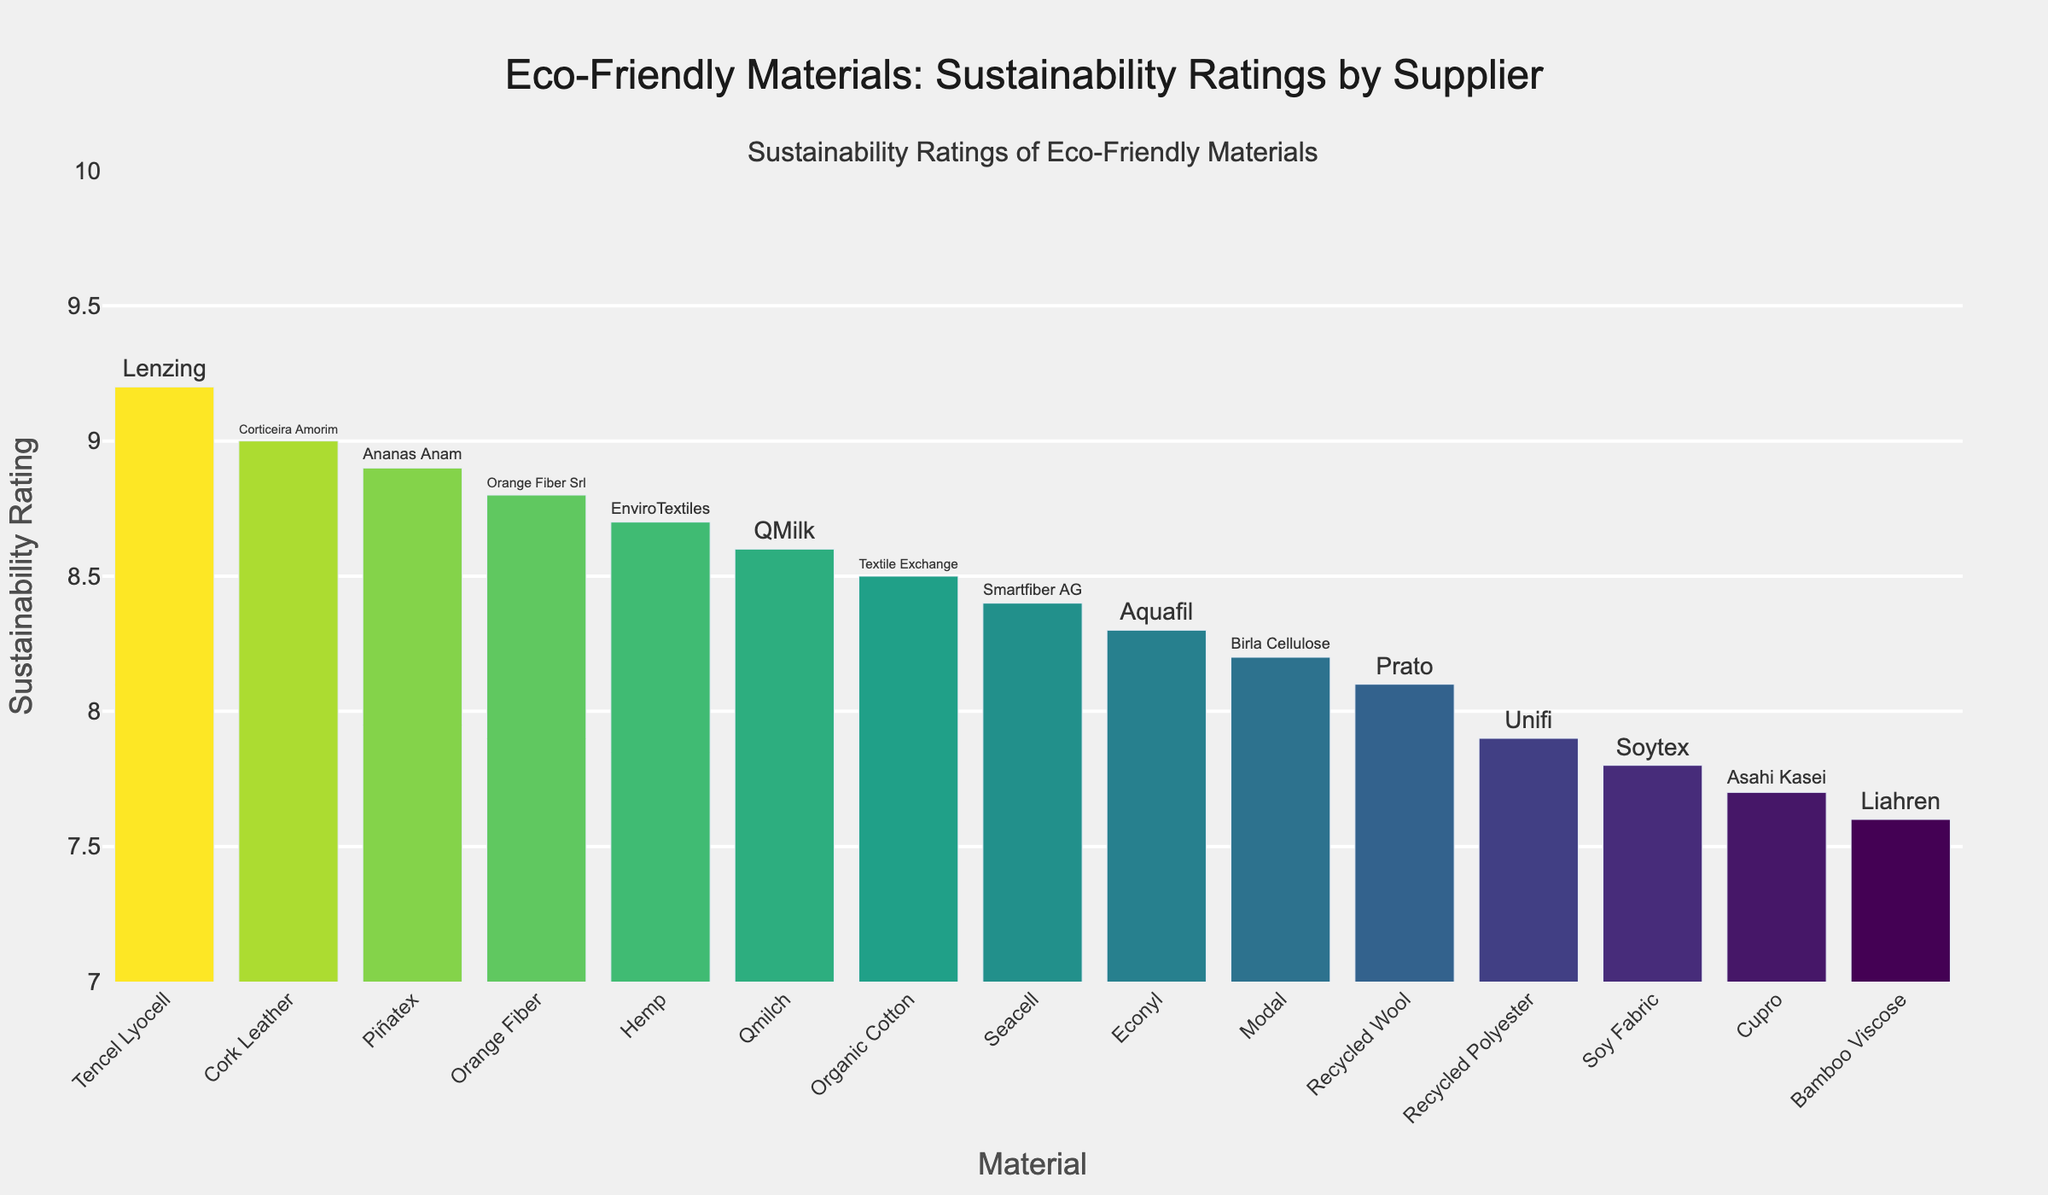What's the material with the highest sustainability rating? The material with the highest bar on the chart is Tencel Lyocell with a rating of 9.2, as indicated at the top of its bar.
Answer: Tencel Lyocell Which material has a higher sustainability rating, Hemp or Bamboo Viscose? By comparing the heights of the two bars, Hemp has a rating of 8.7 while Bamboo Viscose has a rating of 7.6, making Hemp the higher rated material.
Answer: Hemp What is the average sustainability rating of the materials supplied by Textile Exchange and Aquafil? Textile Exchange provides Organic Cotton with a rating of 8.5, and Aquafil supplies Econyl rated at 8.3. Average = (8.5 + 8.3) / 2 = 8.4.
Answer: 8.4 How many materials have a sustainability rating greater than 8.5? Counting the bars higher than 8.5: Tencel Lyocell, Piñatex, Cork Leather, Orange Fiber, Qmilch, and Hemp. This makes a total of 6 materials.
Answer: 6 Which suppliers provide materials with sustainability ratings of exactly 8.9? The bar labeled 8.9 corresponds to Piñatex, which is provided by Ananas Anam.
Answer: Ananas Anam Which material provided by Birla Cellulose, and what is its sustainability rating? By checking the bar labeled with the supplier Birla Cellulose, it corresponds to Modal with a rating of 8.2.
Answer: Modal, 8.2 What is the difference in sustainability ratings between Cupro and Seacell? Cupro has a rating of 7.7, while Seacell is rated at 8.4. Difference = 8.4 - 7.7 = 0.7.
Answer: 0.7 Out of the materials with ratings between 8.0 and 8.5, which is the least sustainable? Materials with ratings between 8.0 and 8.5 are Organic Cotton, Seacell, Econyl, Recycled Wool, and Modal. The least sustainable among them is Recycled Wool with a rating of 8.1.
Answer: Recycled Wool What is the combined sustainability rating of Cork Leather and Orange Fiber? Cork Leather has a rating of 9.0 and Orange Fiber has 8.8. The combined rating is 9.0 + 8.8 = 17.8.
Answer: 17.8 